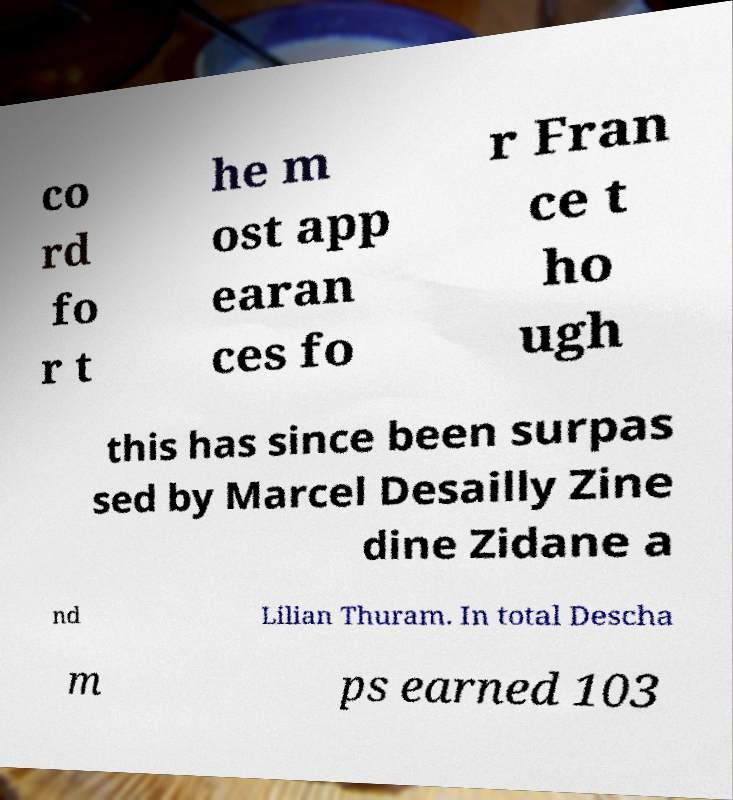Can you accurately transcribe the text from the provided image for me? co rd fo r t he m ost app earan ces fo r Fran ce t ho ugh this has since been surpas sed by Marcel Desailly Zine dine Zidane a nd Lilian Thuram. In total Descha m ps earned 103 